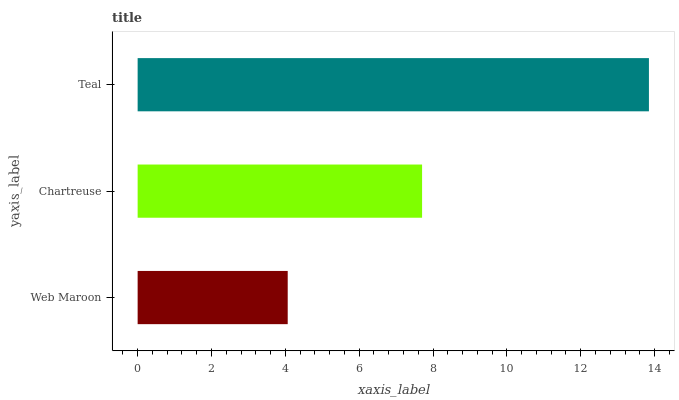Is Web Maroon the minimum?
Answer yes or no. Yes. Is Teal the maximum?
Answer yes or no. Yes. Is Chartreuse the minimum?
Answer yes or no. No. Is Chartreuse the maximum?
Answer yes or no. No. Is Chartreuse greater than Web Maroon?
Answer yes or no. Yes. Is Web Maroon less than Chartreuse?
Answer yes or no. Yes. Is Web Maroon greater than Chartreuse?
Answer yes or no. No. Is Chartreuse less than Web Maroon?
Answer yes or no. No. Is Chartreuse the high median?
Answer yes or no. Yes. Is Chartreuse the low median?
Answer yes or no. Yes. Is Teal the high median?
Answer yes or no. No. Is Web Maroon the low median?
Answer yes or no. No. 